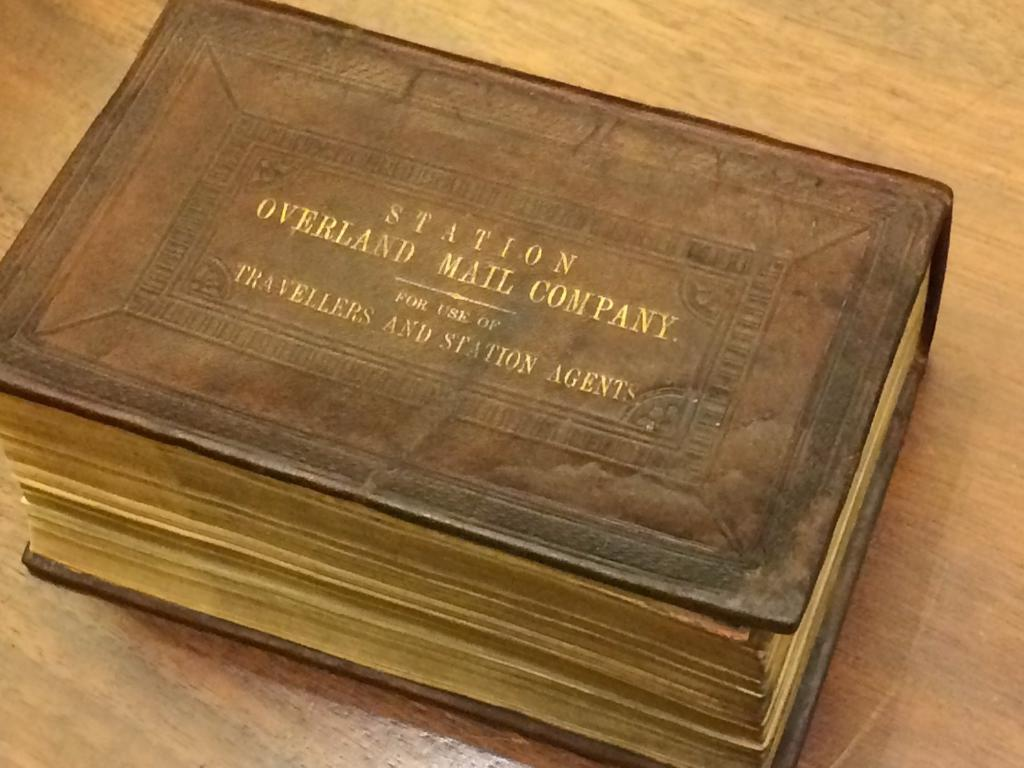<image>
Give a short and clear explanation of the subsequent image. An old leather bound book from the Overland Mail Company is marked for use of travelers and station agents. 